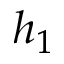Convert formula to latex. <formula><loc_0><loc_0><loc_500><loc_500>h _ { 1 }</formula> 